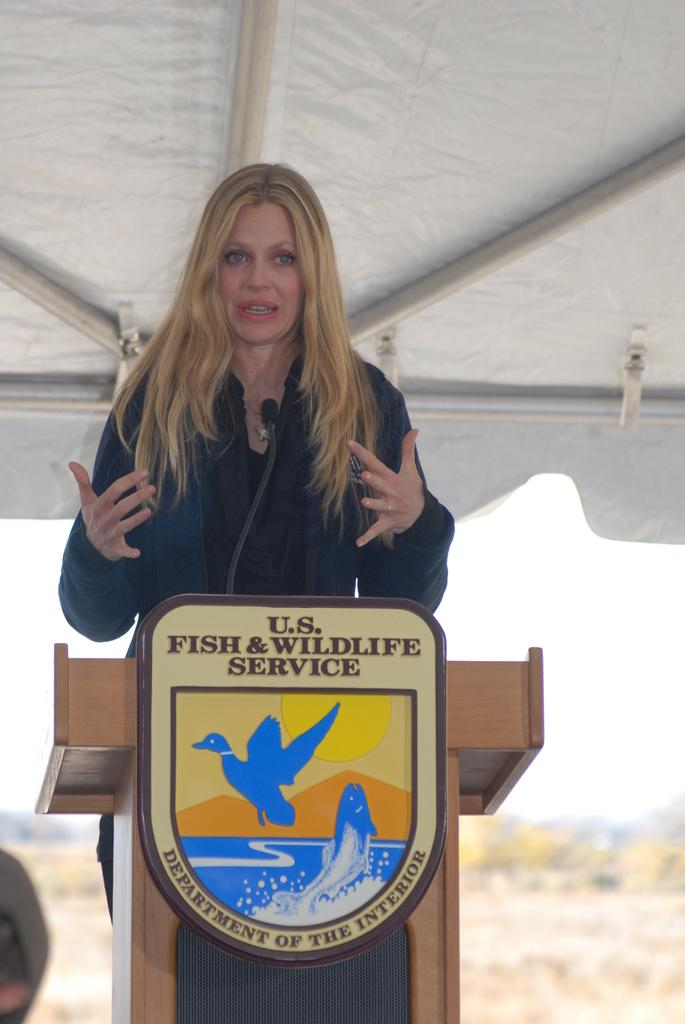<image>
Offer a succinct explanation of the picture presented. A woman is speaking in front of US Fish and Wildlife service 